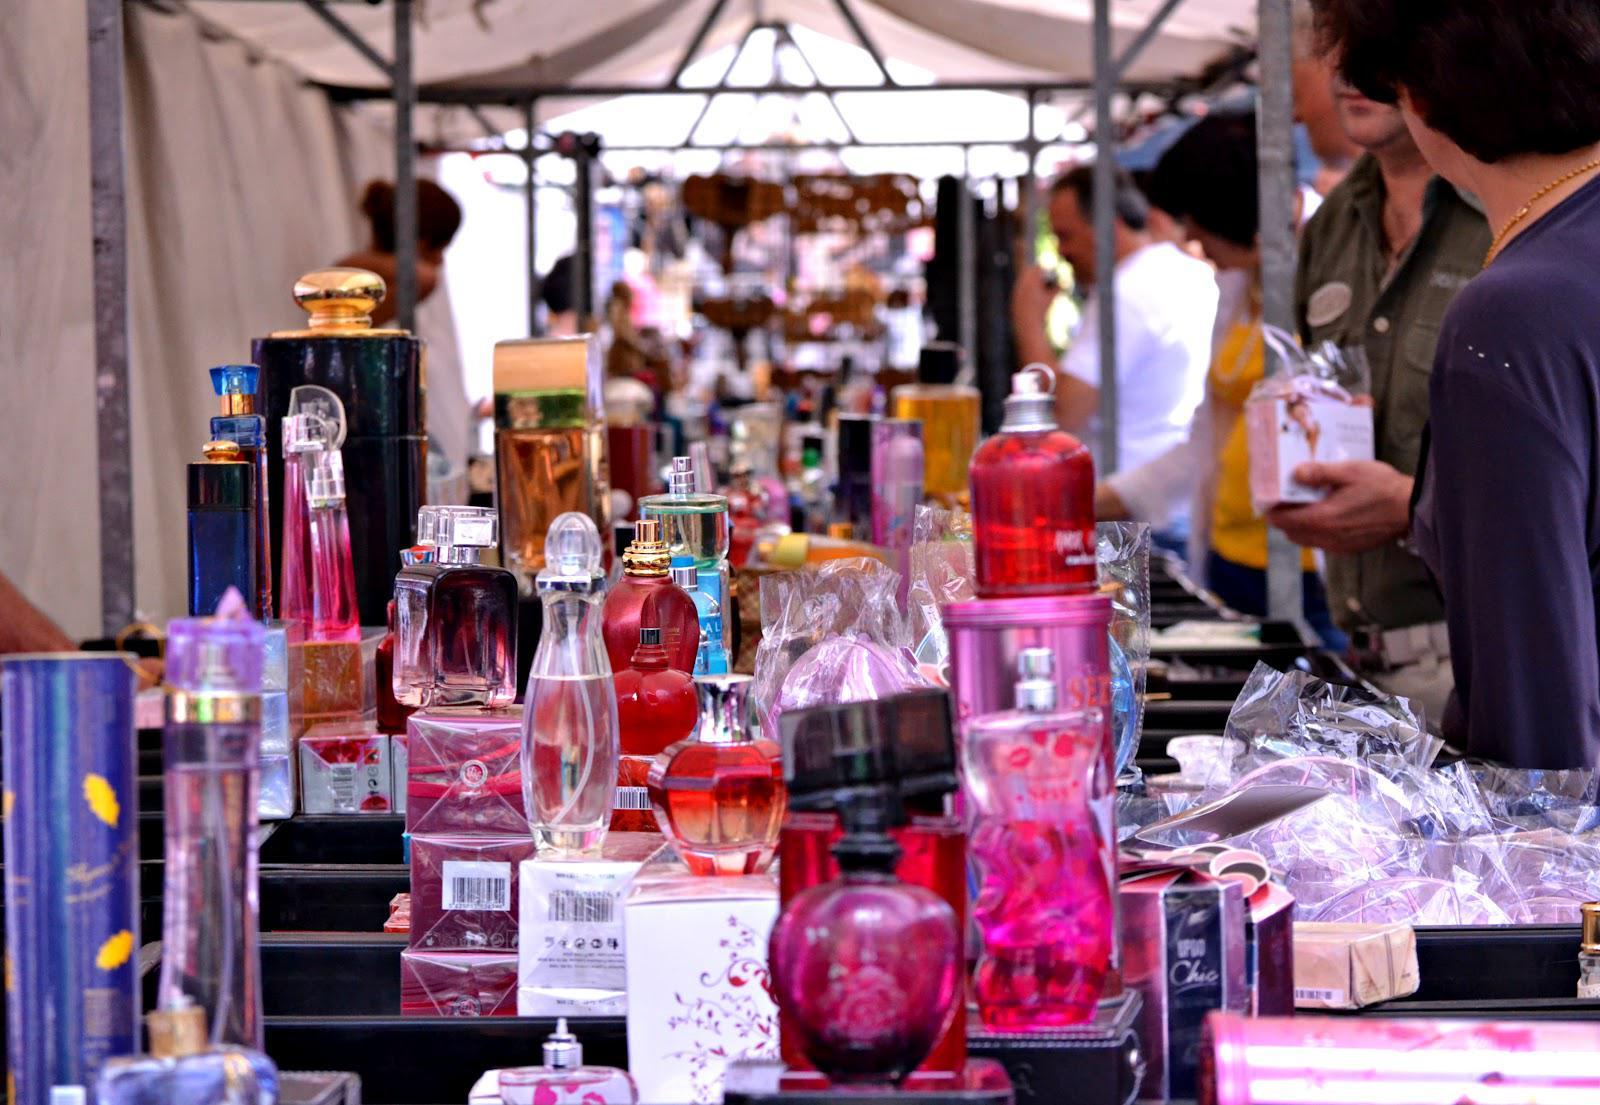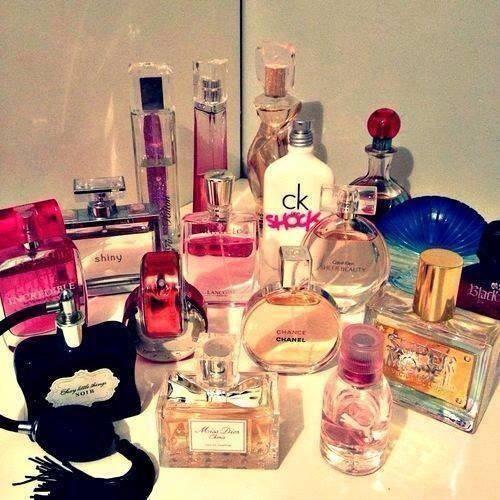The first image is the image on the left, the second image is the image on the right. For the images shown, is this caption "The left image includes a horizontal row of at least five bottles of the same size and shape, but in different fragrance varieties." true? Answer yes or no. No. The first image is the image on the left, the second image is the image on the right. Examine the images to the left and right. Is the description "A person is holding a product." accurate? Answer yes or no. Yes. 